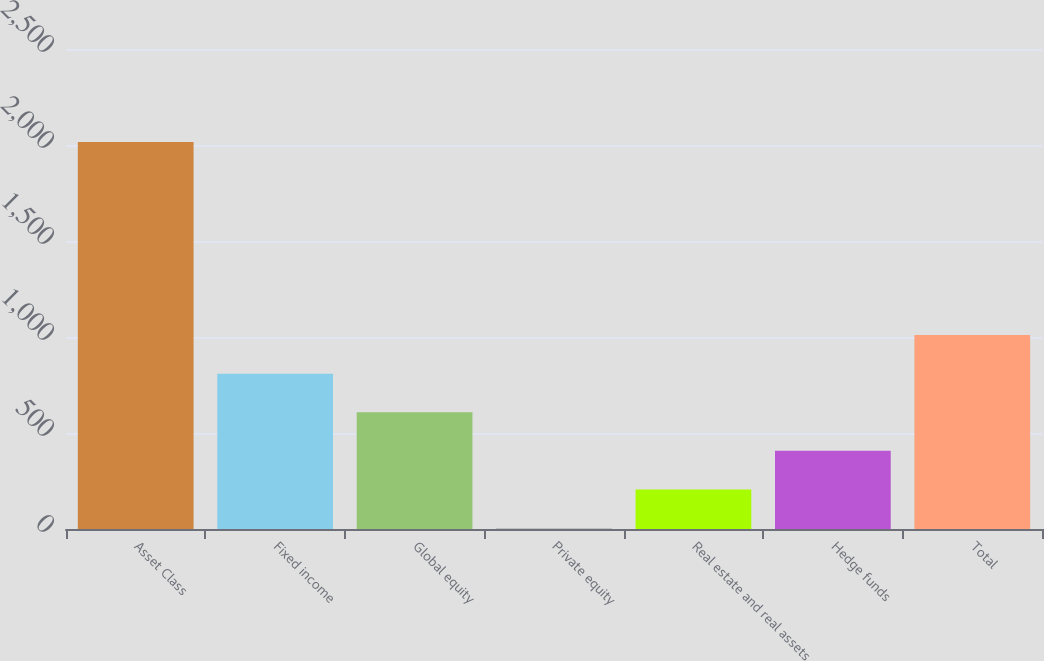<chart> <loc_0><loc_0><loc_500><loc_500><bar_chart><fcel>Asset Class<fcel>Fixed income<fcel>Global equity<fcel>Private equity<fcel>Real estate and real assets<fcel>Hedge funds<fcel>Total<nl><fcel>2015<fcel>809<fcel>608<fcel>5<fcel>206<fcel>407<fcel>1010<nl></chart> 